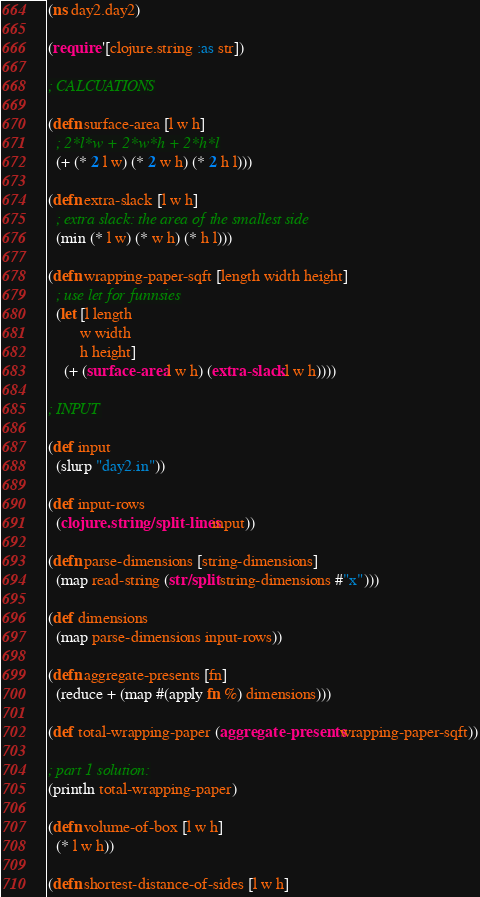Convert code to text. <code><loc_0><loc_0><loc_500><loc_500><_Clojure_>(ns day2.day2)

(require '[clojure.string :as str])

; CALCUATIONS

(defn surface-area [l w h]
  ; 2*l*w + 2*w*h + 2*h*l
  (+ (* 2 l w) (* 2 w h) (* 2 h l)))

(defn extra-slack [l w h]
  ; extra slack: the area of the smallest side
  (min (* l w) (* w h) (* h l)))

(defn wrapping-paper-sqft [length width height]
  ; use let for funnsies
  (let [l length
        w width
        h height]
    (+ (surface-area l w h) (extra-slack l w h))))

; INPUT

(def input
  (slurp "day2.in"))

(def input-rows
  (clojure.string/split-lines input))

(defn parse-dimensions [string-dimensions]
  (map read-string (str/split string-dimensions #"x")))

(def dimensions
  (map parse-dimensions input-rows))

(defn aggregate-presents [fn]
  (reduce + (map #(apply fn %) dimensions)))

(def total-wrapping-paper (aggregate-presents wrapping-paper-sqft))

; part 1 solution:
(println total-wrapping-paper)

(defn volume-of-box [l w h]
  (* l w h))

(defn shortest-distance-of-sides [l w h]</code> 